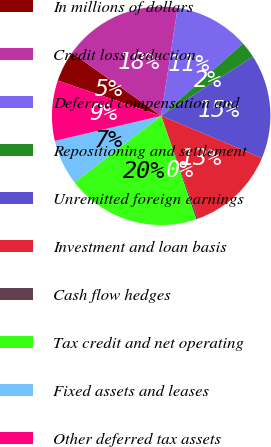Convert chart. <chart><loc_0><loc_0><loc_500><loc_500><pie_chart><fcel>In millions of dollars<fcel>Credit loss deduction<fcel>Deferred compensation and<fcel>Repositioning and settlement<fcel>Unremitted foreign earnings<fcel>Investment and loan basis<fcel>Cash flow hedges<fcel>Tax credit and net operating<fcel>Fixed assets and leases<fcel>Other deferred tax assets<nl><fcel>4.57%<fcel>17.61%<fcel>11.09%<fcel>2.39%<fcel>15.43%<fcel>13.26%<fcel>0.22%<fcel>19.78%<fcel>6.74%<fcel>8.91%<nl></chart> 